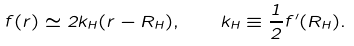Convert formula to latex. <formula><loc_0><loc_0><loc_500><loc_500>f ( r ) \simeq 2 k _ { H } ( r - R _ { H } ) , \quad k _ { H } \equiv \frac { 1 } { 2 } f ^ { \prime } ( R _ { H } ) .</formula> 